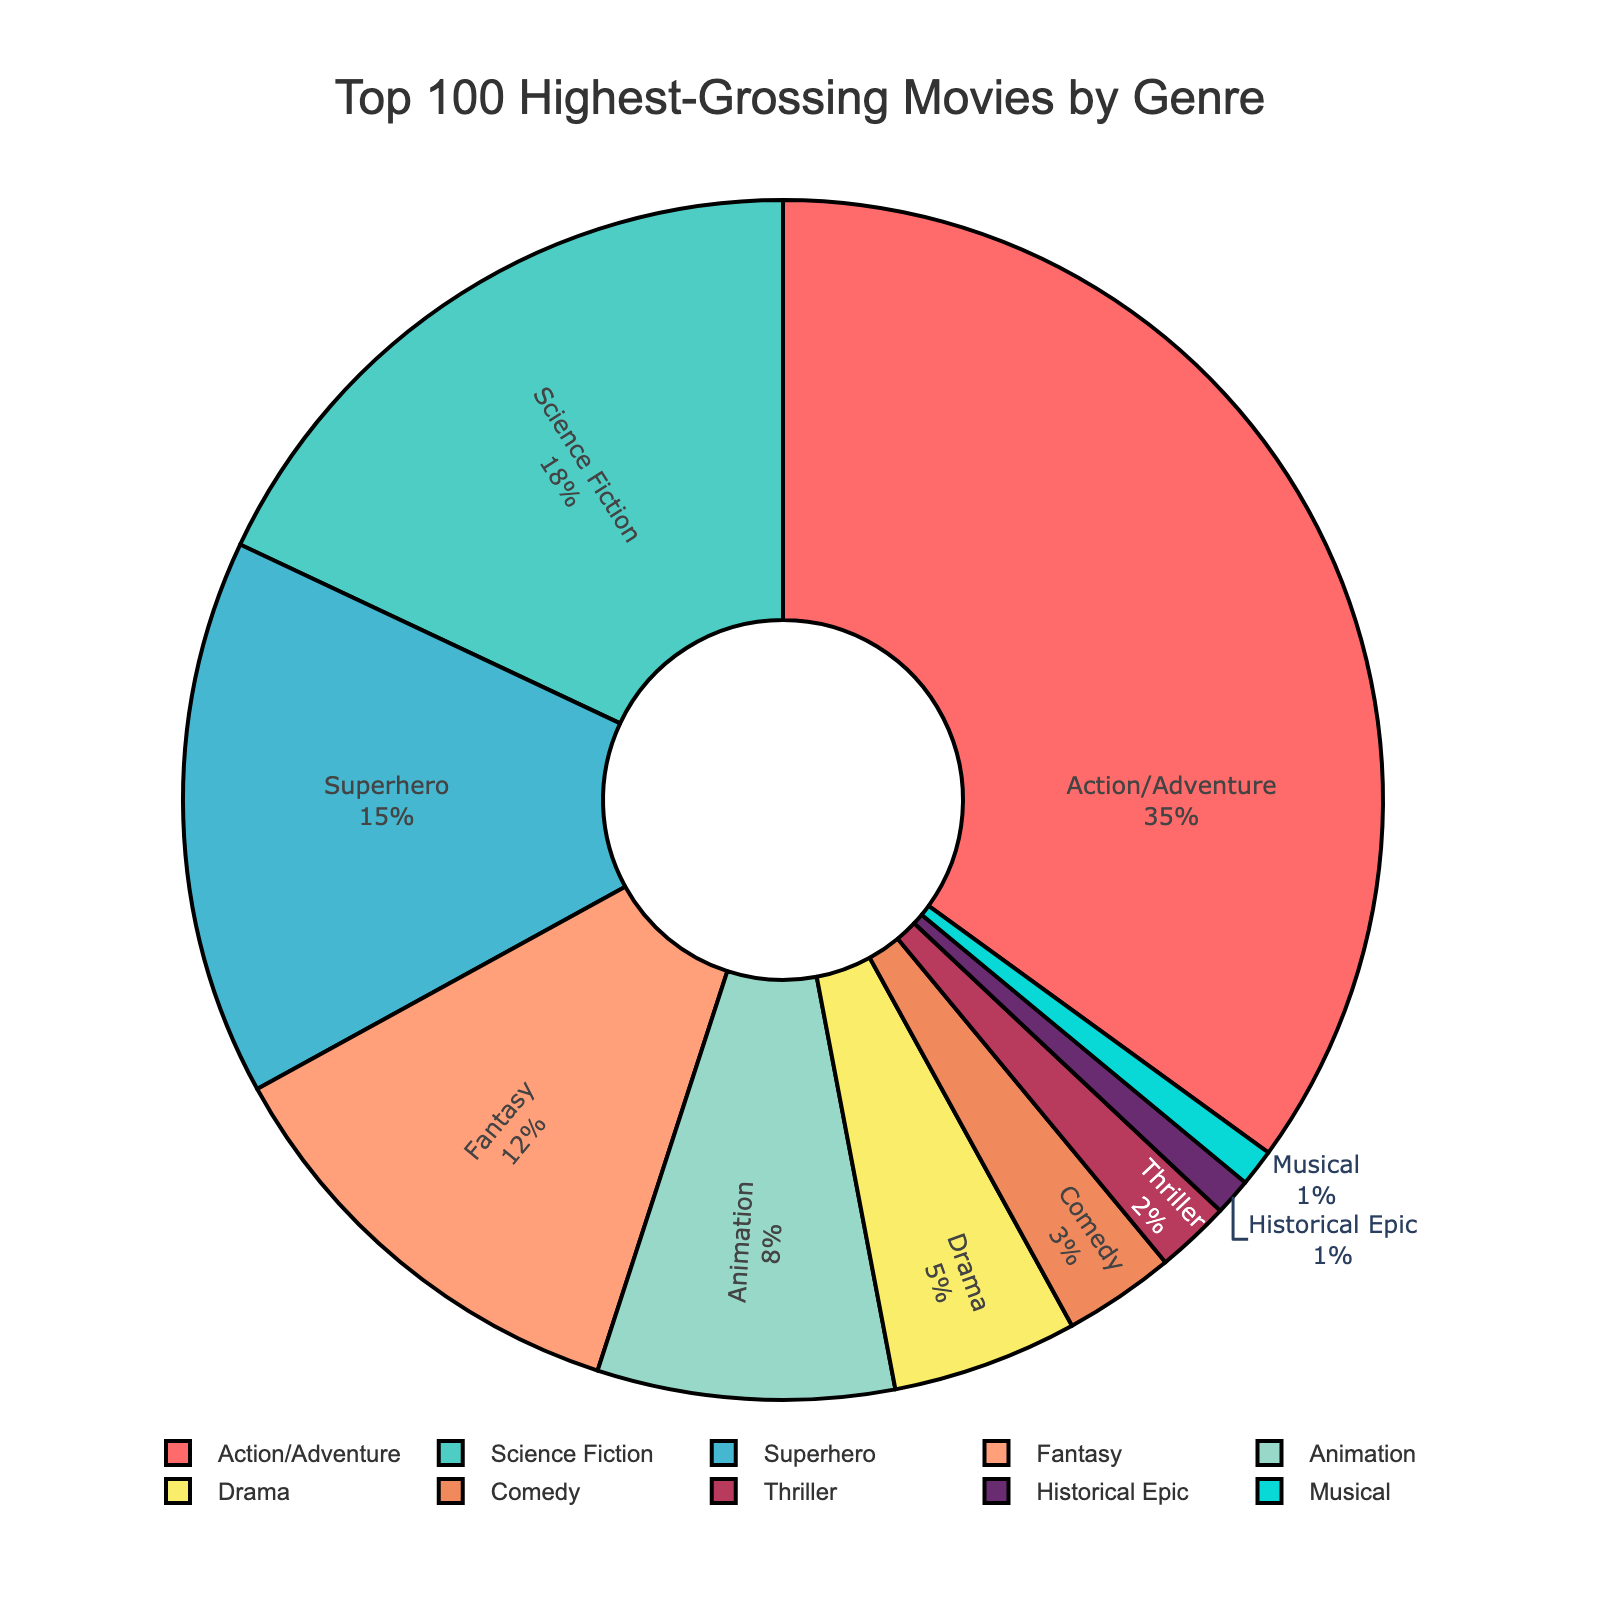Which genre has the highest percentage in the pie chart? The "Action/Adventure" genre has the highest percentage. This can be seen by looking at the section with the largest area in the pie chart.
Answer: Action/Adventure What is the combined percentage of the top three genres? The percentages of the top three genres are Action/Adventure (35%), Science Fiction (18%), and Superhero (15%). Adding these together: 35% + 18% + 15% = 68%.
Answer: 68% Which genre occupies a smaller percentage, Musical or Historical Epic? By comparing the slices of the pie chart labeled "Musical" and "Historical Epic," both are very small, but we can see from the data that both are 1%.
Answer: Equal How much larger is the percentage of Superhero movies compared to Drama movies? The percentage for Superhero movies is 15%, and for Drama movies, it is 5%. Subtracting these values gives 15% - 5% = 10%.
Answer: 10% What is the percentage difference between Animation and Comedy genres? The percentage for Animation is 8%, and for Comedy it is 3%. Subtracting these values gives 8% - 3% = 5%.
Answer: 5% Which genre occupies the smallest percentage in the chart and what is it? Both the "Musical" and "Historical Epic" genres occupy the smallest percentages in the pie chart, both at 1%.
Answer: Musical and Historical Epic, 1% How does the percentage of Fantasy movies compare to that of Science Fiction? The percentage for Fantasy movies is 12%, while Science Fiction movies have 18%. This shows that Science Fiction has a higher percentage. Comparison: 12% < 18%.
Answer: Science Fiction has a higher percentage Sum up the percentages of genres that have less than 10% each. The genres with less than 10% are Animation (8%), Drama (5%), Comedy (3%), Thriller (2%), Historical Epic (1%), and Musical (1%). Adding these: 8% + 5% + 3% + 2% + 1% + 1% = 20%.
Answer: 20% How many genres have percentages greater than 10%? By inspecting the pie chart, the genres with percentages over 10% are Action/Adventure (35%), Science Fiction (18%), Superhero (15%), and Fantasy (12%). This totals four genres.
Answer: 4 genres What is the total percentage represented by genres not in the top four? The top four genres are Action/Adventure (35%), Science Fiction (18%), Superhero (15%), and Fantasy (12%), summing to 80%. The total for all genres is 100%, so the remaining genres account for 100% - 80% = 20%.
Answer: 20% 